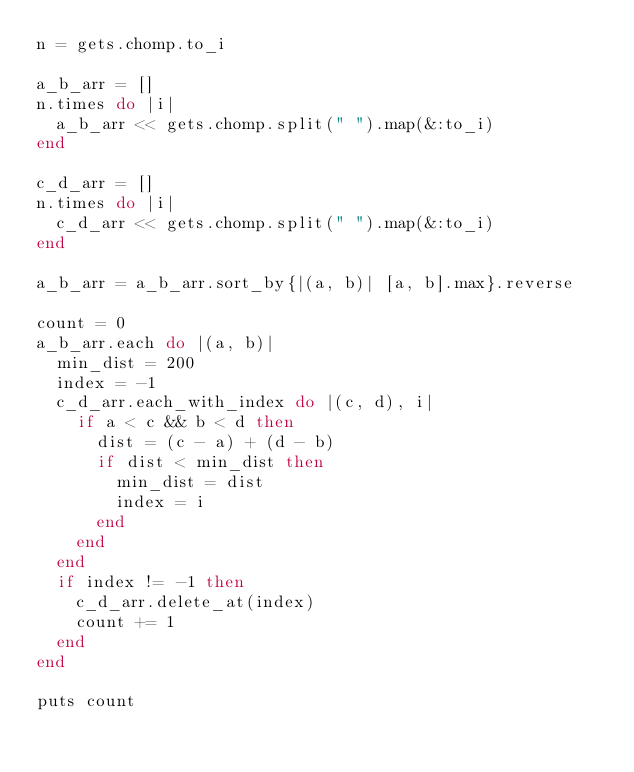<code> <loc_0><loc_0><loc_500><loc_500><_Ruby_>n = gets.chomp.to_i

a_b_arr = []
n.times do |i|
  a_b_arr << gets.chomp.split(" ").map(&:to_i)
end

c_d_arr = []
n.times do |i|
  c_d_arr << gets.chomp.split(" ").map(&:to_i)
end

a_b_arr = a_b_arr.sort_by{|(a, b)| [a, b].max}.reverse

count = 0
a_b_arr.each do |(a, b)|
  min_dist = 200
  index = -1
  c_d_arr.each_with_index do |(c, d), i|
    if a < c && b < d then
      dist = (c - a) + (d - b)
      if dist < min_dist then
        min_dist = dist
        index = i
      end
    end
  end
  if index != -1 then
    c_d_arr.delete_at(index)
    count += 1
  end
end

puts count
</code> 